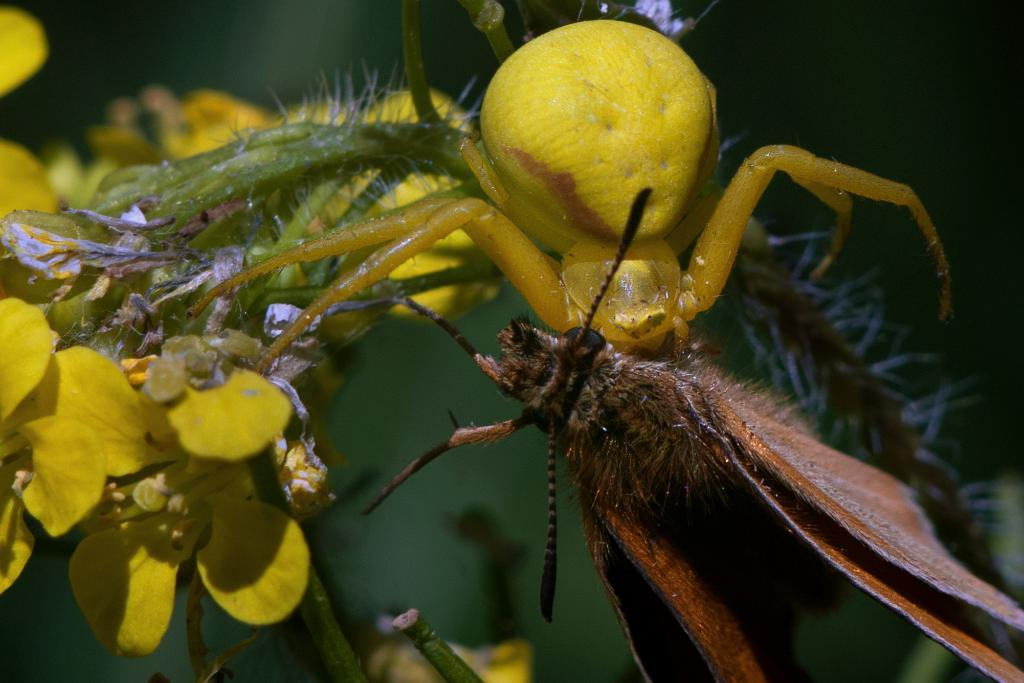What type of insects can be seen in the image? There is a yellow color insect and a brown color insect in the image. Where are the insects located? Both insects are on a plant. What other features can be observed on the plant? There are yellow color flowers on the plant. How would you describe the background of the image? The background of the image is blurry. What type of camera can be seen in the image? There is no camera present in the image. Is there a water source visible in the image? There is no water source visible in the image. 